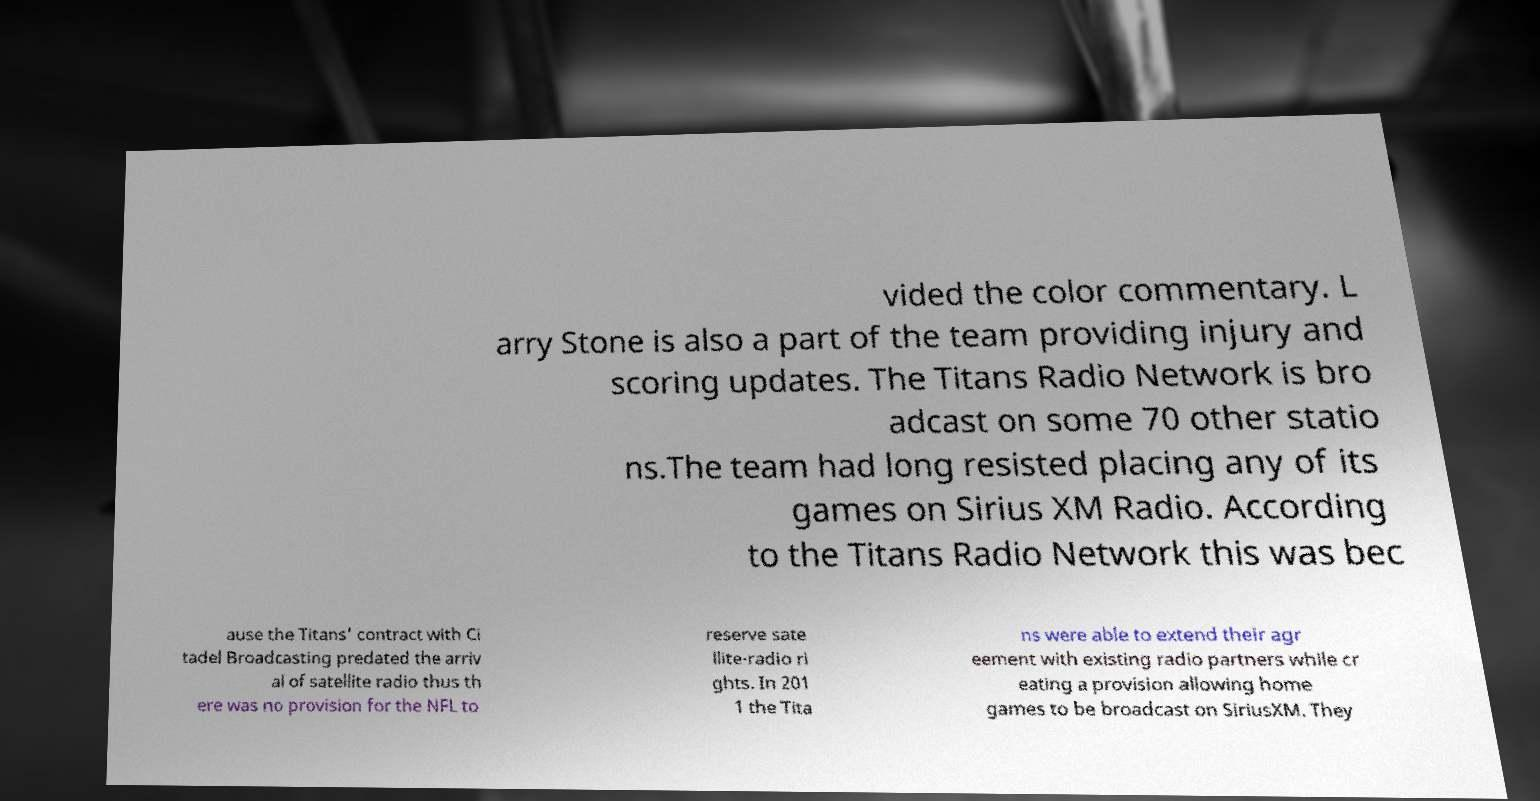For documentation purposes, I need the text within this image transcribed. Could you provide that? vided the color commentary. L arry Stone is also a part of the team providing injury and scoring updates. The Titans Radio Network is bro adcast on some 70 other statio ns.The team had long resisted placing any of its games on Sirius XM Radio. According to the Titans Radio Network this was bec ause the Titans' contract with Ci tadel Broadcasting predated the arriv al of satellite radio thus th ere was no provision for the NFL to reserve sate llite-radio ri ghts. In 201 1 the Tita ns were able to extend their agr eement with existing radio partners while cr eating a provision allowing home games to be broadcast on SiriusXM. They 